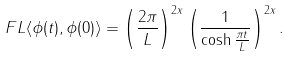Convert formula to latex. <formula><loc_0><loc_0><loc_500><loc_500>\ F L \langle \phi ( t ) , \phi ( 0 ) \rangle = \left ( \frac { 2 \pi } { L } \right ) ^ { 2 x } \left ( \frac { 1 } { \cosh \frac { \pi t } { L } } \right ) ^ { 2 x } .</formula> 